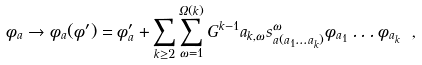<formula> <loc_0><loc_0><loc_500><loc_500>\phi _ { a } \to \phi _ { a } ( \phi ^ { \prime } ) = \phi ^ { \prime } _ { a } + \sum _ { k \geq 2 } \sum _ { \omega = 1 } ^ { \Omega ( k ) } G ^ { k - 1 } a _ { k , \omega } s ^ { \omega } _ { a ( a _ { 1 } \dots a _ { k } ) } \phi _ { a _ { 1 } } \dots \phi _ { a _ { k } } \ ,</formula> 